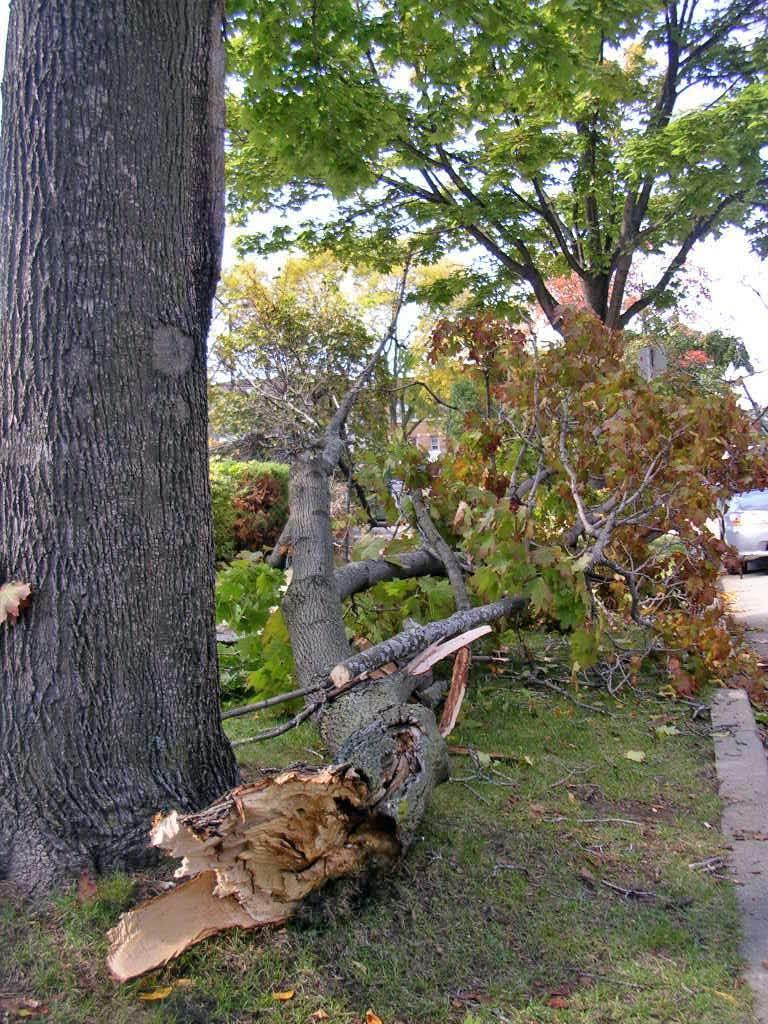What type of vegetation is present in the image? There are trees on a grassy land in the image. Where are the trees located in relation to the image? The trees are in the middle of the image. What can be seen in the background of the image? The sky is visible in the background of the image. What type of man-made object is present on the right side of the image? There appears to be a car on the right side of the image. How many sisters are playing with the square in the image? There are no sisters or squares present in the image. 